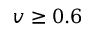<formula> <loc_0><loc_0><loc_500><loc_500>v \geq 0 . 6</formula> 